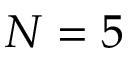<formula> <loc_0><loc_0><loc_500><loc_500>N = 5</formula> 